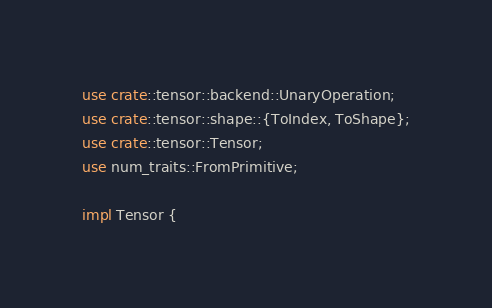Convert code to text. <code><loc_0><loc_0><loc_500><loc_500><_Rust_>use crate::tensor::backend::UnaryOperation;
use crate::tensor::shape::{ToIndex, ToShape};
use crate::tensor::Tensor;
use num_traits::FromPrimitive;

impl Tensor {</code> 